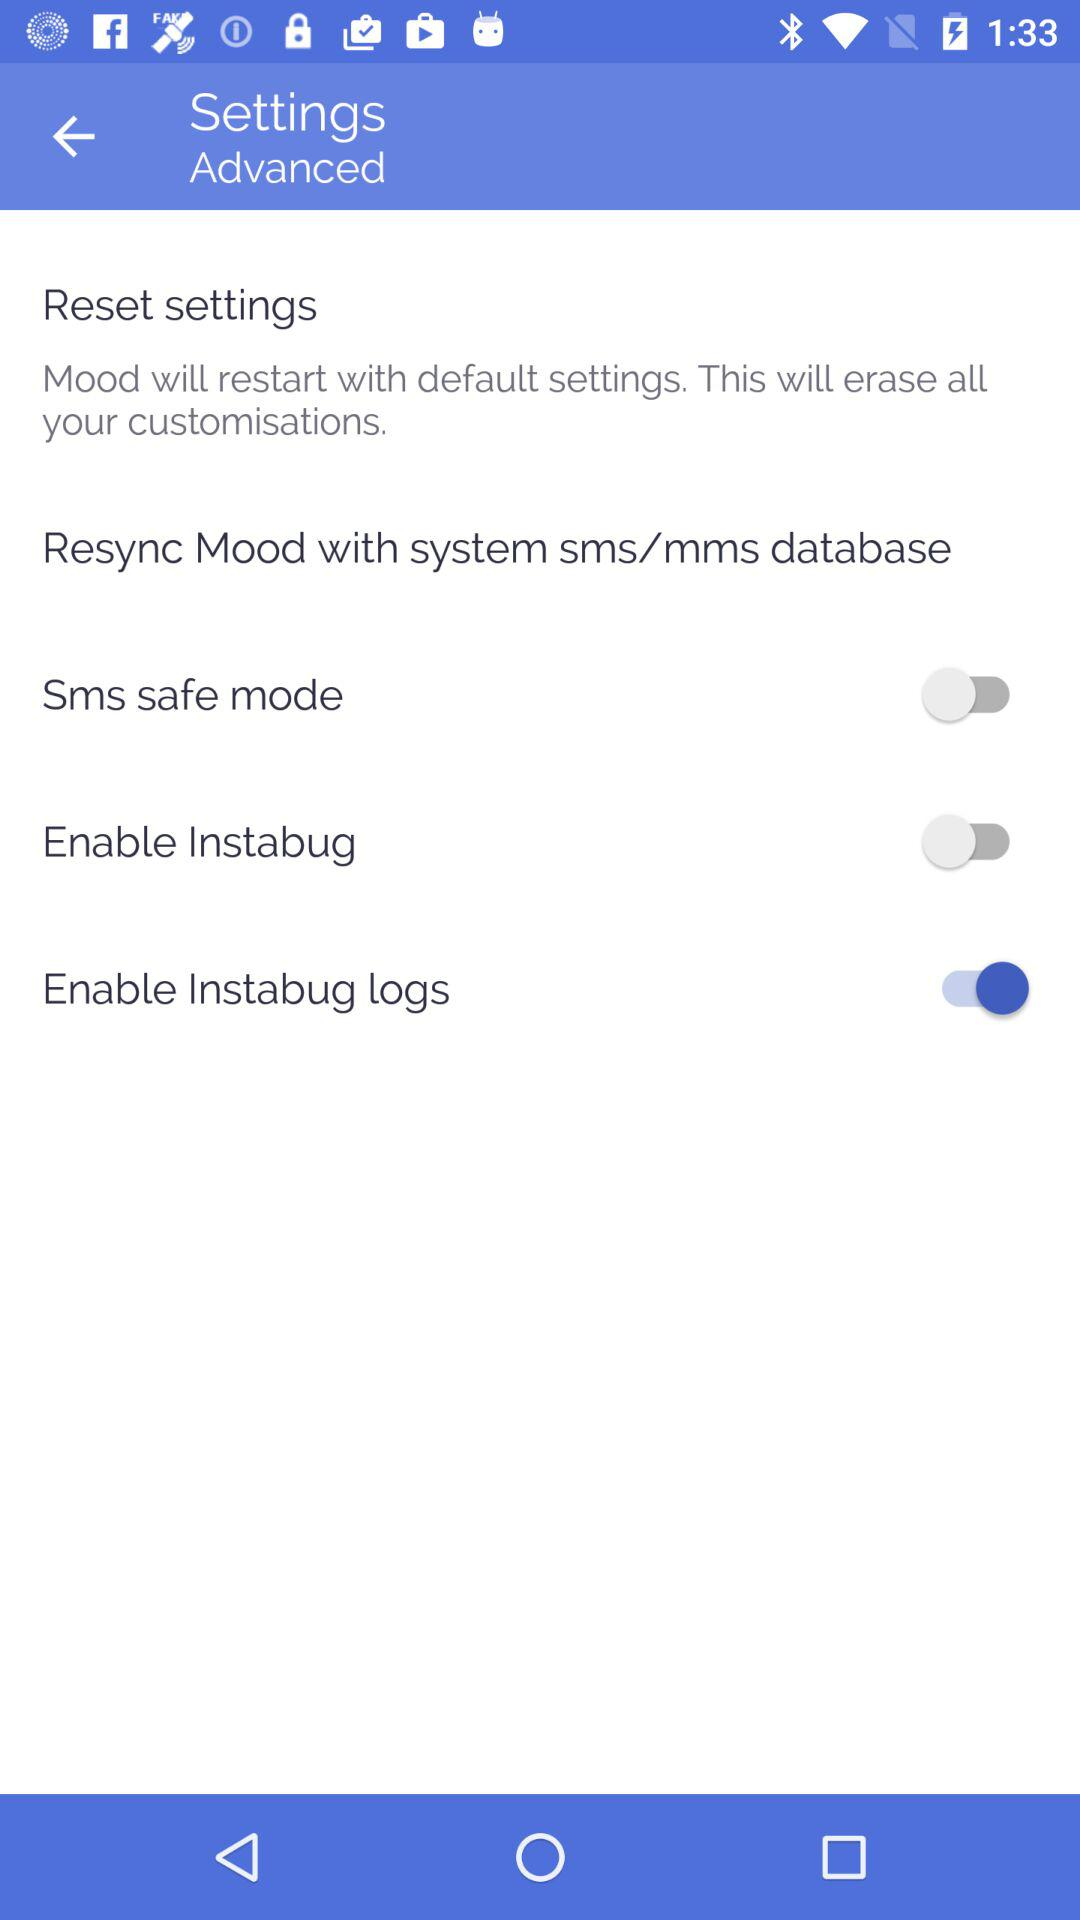What's the status of the "Sms safe mode"? The status of the "Sms safe mode" is "off". 